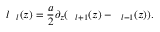<formula> <loc_0><loc_0><loc_500><loc_500>l \xi _ { l } ( z ) = \frac { a } { 2 } \partial _ { z } ( \xi _ { l + 1 } ( z ) - \xi _ { l - 1 } ( z ) ) .</formula> 